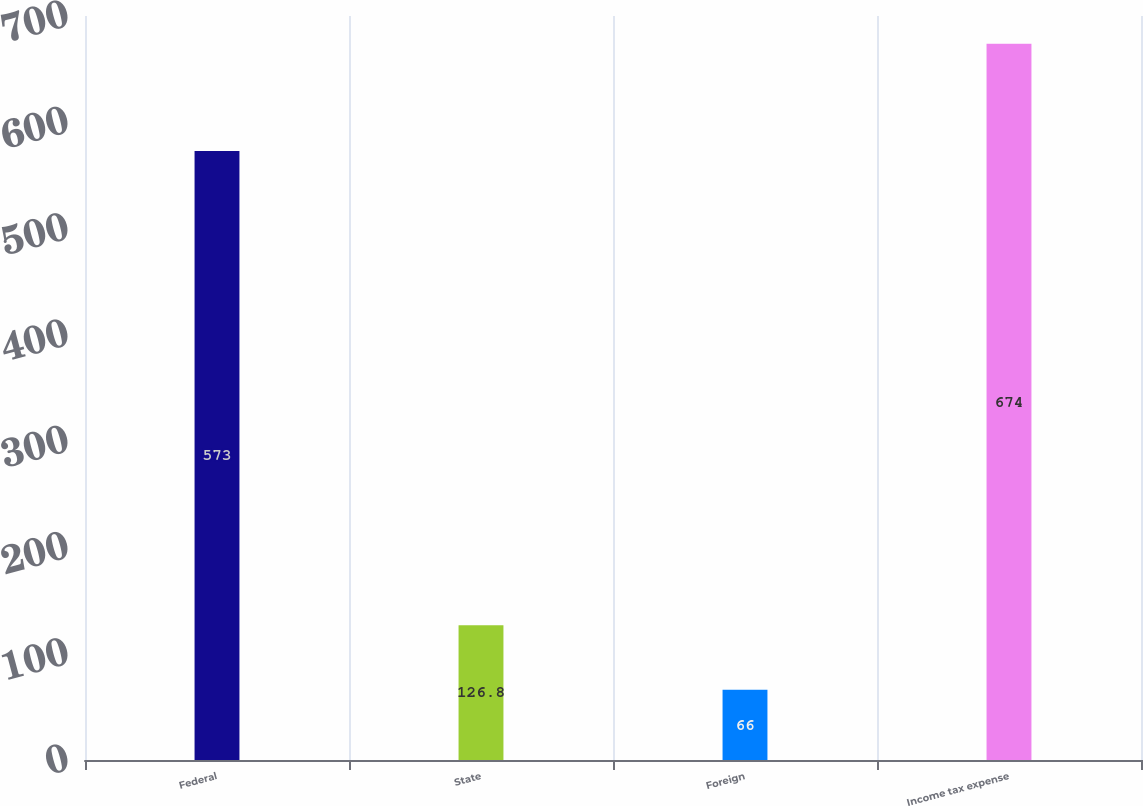<chart> <loc_0><loc_0><loc_500><loc_500><bar_chart><fcel>Federal<fcel>State<fcel>Foreign<fcel>Income tax expense<nl><fcel>573<fcel>126.8<fcel>66<fcel>674<nl></chart> 